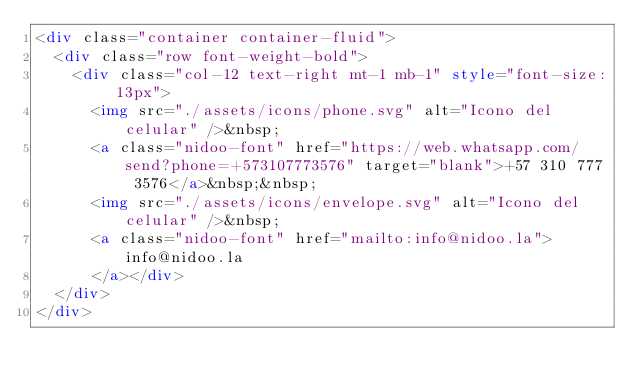<code> <loc_0><loc_0><loc_500><loc_500><_HTML_><div class="container container-fluid">
  <div class="row font-weight-bold">
    <div class="col-12 text-right mt-1 mb-1" style="font-size: 13px">
      <img src="./assets/icons/phone.svg" alt="Icono del celular" />&nbsp;
      <a class="nidoo-font" href="https://web.whatsapp.com/send?phone=+573107773576" target="blank">+57 310 777 3576</a>&nbsp;&nbsp;
      <img src="./assets/icons/envelope.svg" alt="Icono del celular" />&nbsp;
      <a class="nidoo-font" href="mailto:info@nidoo.la">info@nidoo.la
      </a></div>
  </div>
</div>
</code> 